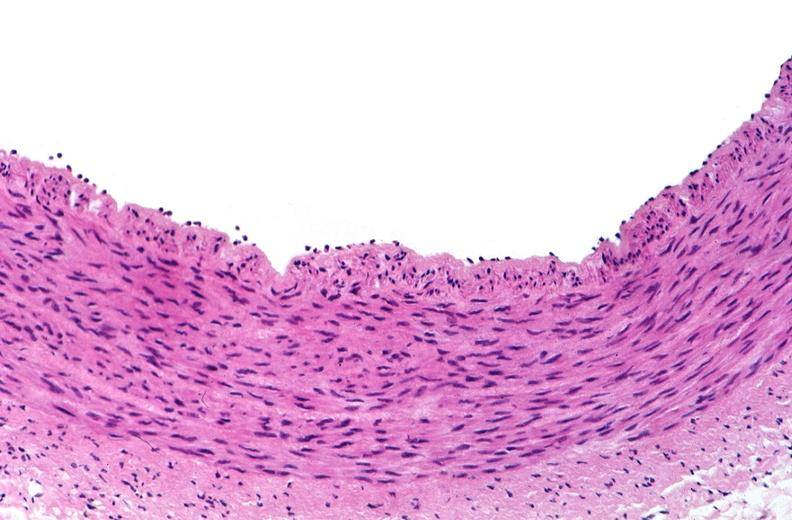what is present?
Answer the question using a single word or phrase. Vasculature 